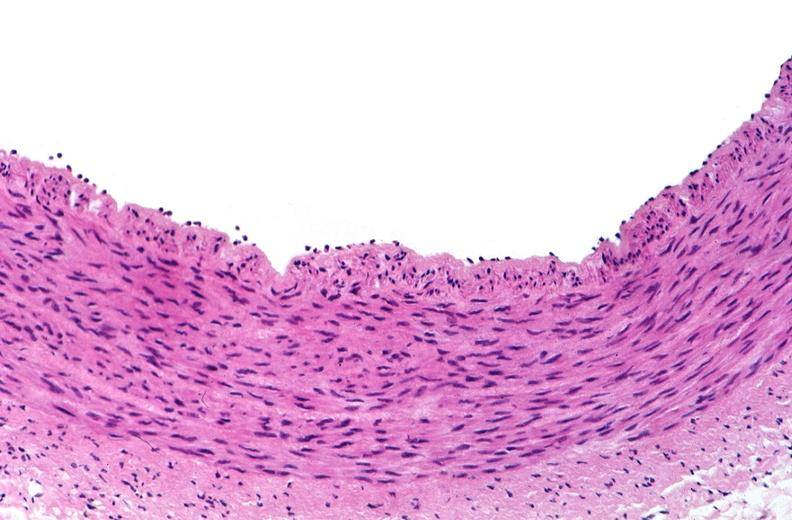what is present?
Answer the question using a single word or phrase. Vasculature 